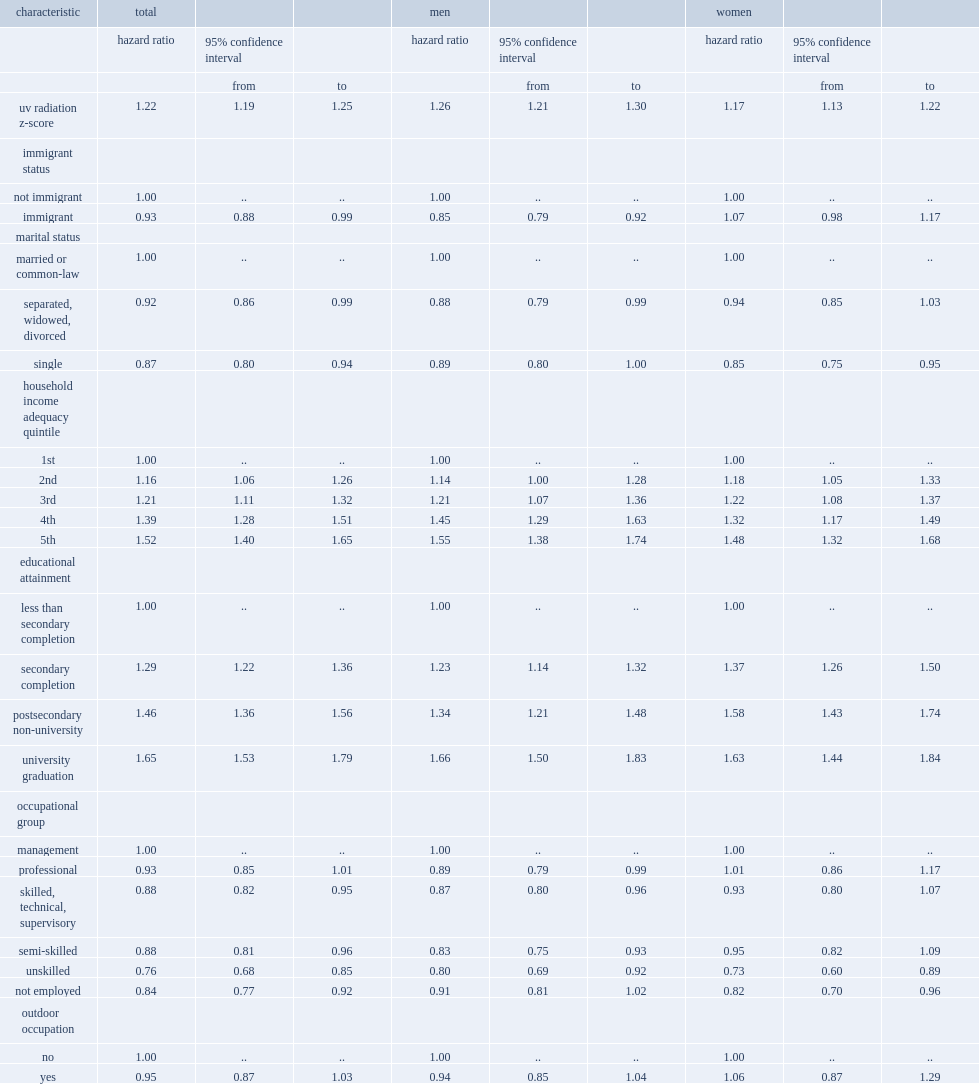What is the hr for melanoma associated with a 1 s.d. increase in the z-score of ambient uvr for both sexes when adjusting for all covariates? 1.22. For men, what is the hr for melanoma associated with ambient uvr? 1.26. 